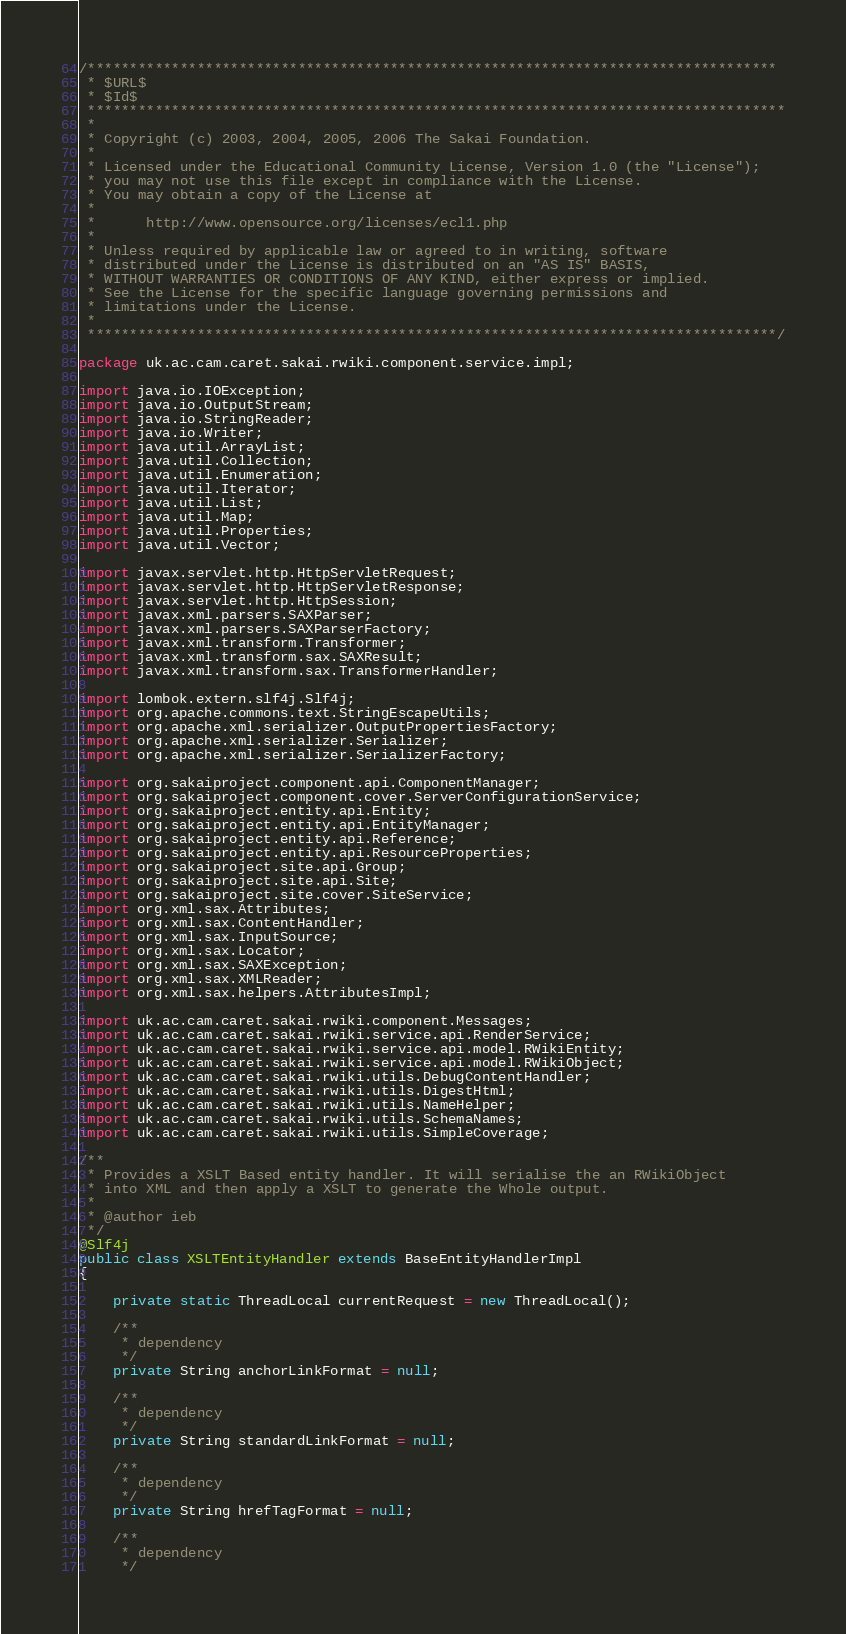Convert code to text. <code><loc_0><loc_0><loc_500><loc_500><_Java_>/**********************************************************************************
 * $URL$
 * $Id$
 ***********************************************************************************
 *
 * Copyright (c) 2003, 2004, 2005, 2006 The Sakai Foundation.
 *
 * Licensed under the Educational Community License, Version 1.0 (the "License");
 * you may not use this file except in compliance with the License.
 * You may obtain a copy of the License at
 *
 *      http://www.opensource.org/licenses/ecl1.php
 *
 * Unless required by applicable law or agreed to in writing, software
 * distributed under the License is distributed on an "AS IS" BASIS,
 * WITHOUT WARRANTIES OR CONDITIONS OF ANY KIND, either express or implied.
 * See the License for the specific language governing permissions and
 * limitations under the License.
 *
 **********************************************************************************/

package uk.ac.cam.caret.sakai.rwiki.component.service.impl;

import java.io.IOException;
import java.io.OutputStream;
import java.io.StringReader;
import java.io.Writer;
import java.util.ArrayList;
import java.util.Collection;
import java.util.Enumeration;
import java.util.Iterator;
import java.util.List;
import java.util.Map;
import java.util.Properties;
import java.util.Vector;

import javax.servlet.http.HttpServletRequest;
import javax.servlet.http.HttpServletResponse;
import javax.servlet.http.HttpSession;
import javax.xml.parsers.SAXParser;
import javax.xml.parsers.SAXParserFactory;
import javax.xml.transform.Transformer;
import javax.xml.transform.sax.SAXResult;
import javax.xml.transform.sax.TransformerHandler;

import lombok.extern.slf4j.Slf4j;
import org.apache.commons.text.StringEscapeUtils;
import org.apache.xml.serializer.OutputPropertiesFactory;
import org.apache.xml.serializer.Serializer;
import org.apache.xml.serializer.SerializerFactory;

import org.sakaiproject.component.api.ComponentManager;
import org.sakaiproject.component.cover.ServerConfigurationService;
import org.sakaiproject.entity.api.Entity;
import org.sakaiproject.entity.api.EntityManager;
import org.sakaiproject.entity.api.Reference;
import org.sakaiproject.entity.api.ResourceProperties;
import org.sakaiproject.site.api.Group;
import org.sakaiproject.site.api.Site;
import org.sakaiproject.site.cover.SiteService;
import org.xml.sax.Attributes;
import org.xml.sax.ContentHandler;
import org.xml.sax.InputSource;
import org.xml.sax.Locator;
import org.xml.sax.SAXException;
import org.xml.sax.XMLReader;
import org.xml.sax.helpers.AttributesImpl;

import uk.ac.cam.caret.sakai.rwiki.component.Messages;
import uk.ac.cam.caret.sakai.rwiki.service.api.RenderService;
import uk.ac.cam.caret.sakai.rwiki.service.api.model.RWikiEntity;
import uk.ac.cam.caret.sakai.rwiki.service.api.model.RWikiObject;
import uk.ac.cam.caret.sakai.rwiki.utils.DebugContentHandler;
import uk.ac.cam.caret.sakai.rwiki.utils.DigestHtml;
import uk.ac.cam.caret.sakai.rwiki.utils.NameHelper;
import uk.ac.cam.caret.sakai.rwiki.utils.SchemaNames;
import uk.ac.cam.caret.sakai.rwiki.utils.SimpleCoverage;

/**
 * Provides a XSLT Based entity handler. It will serialise the an RWikiObject
 * into XML and then apply a XSLT to generate the Whole output.
 * 
 * @author ieb
 */
@Slf4j
public class XSLTEntityHandler extends BaseEntityHandlerImpl
{

	private static ThreadLocal currentRequest = new ThreadLocal();

	/**
	 * dependency
	 */
	private String anchorLinkFormat = null;

	/**
	 * dependency
	 */
	private String standardLinkFormat = null;

	/**
	 * dependency
	 */
	private String hrefTagFormat = null;

	/**
	 * dependency
	 */</code> 